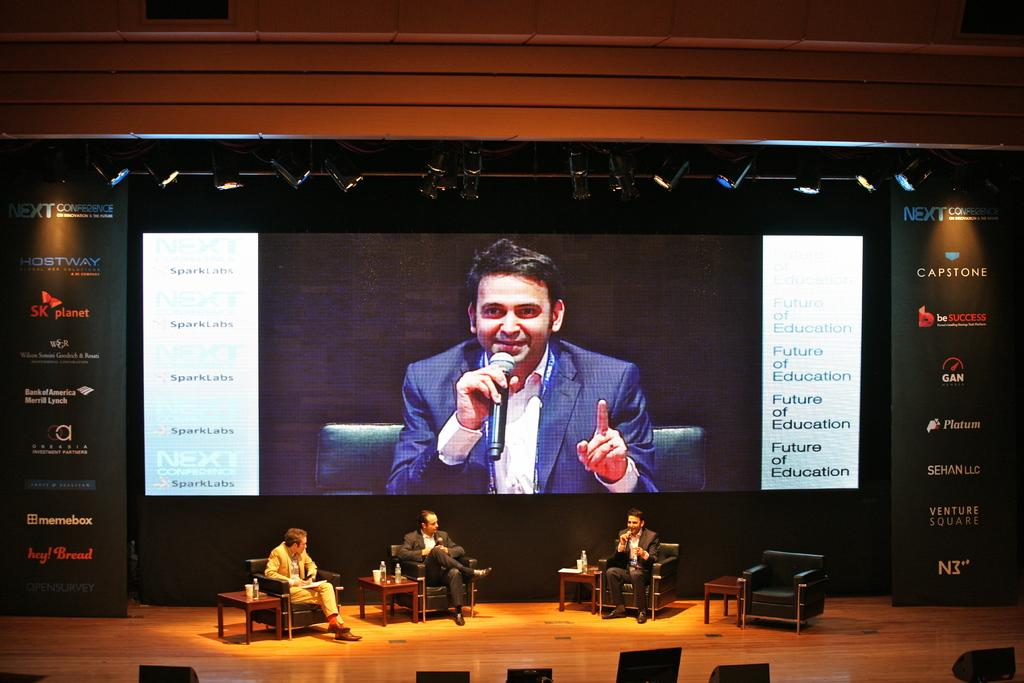Provide a one-sentence caption for the provided image. A large screen with a person and several captions saying Future of education. 